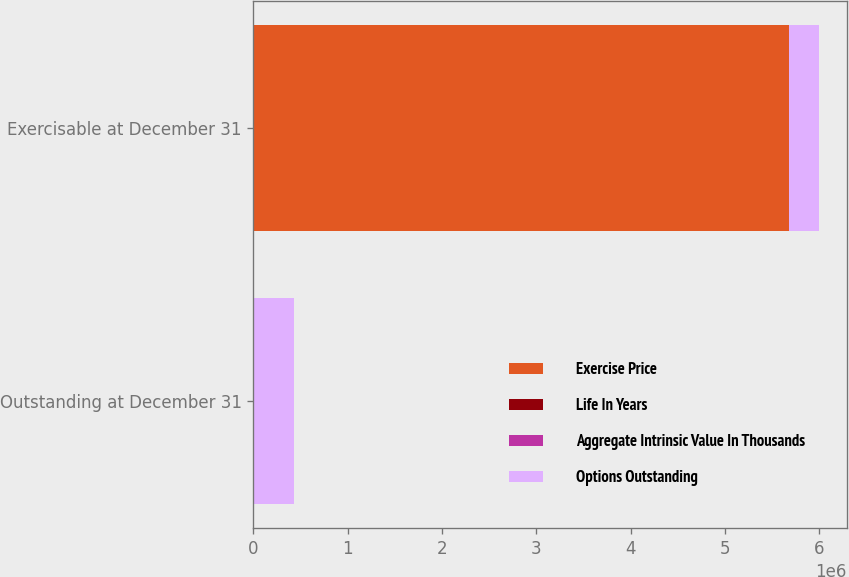Convert chart to OTSL. <chart><loc_0><loc_0><loc_500><loc_500><stacked_bar_chart><ecel><fcel>Outstanding at December 31<fcel>Exercisable at December 31<nl><fcel>Exercise Price<fcel>81.71<fcel>5.67432e+06<nl><fcel>Life In Years<fcel>81.71<fcel>66.33<nl><fcel>Aggregate Intrinsic Value In Thousands<fcel>6<fcel>4.3<nl><fcel>Options Outstanding<fcel>431136<fcel>316820<nl></chart> 